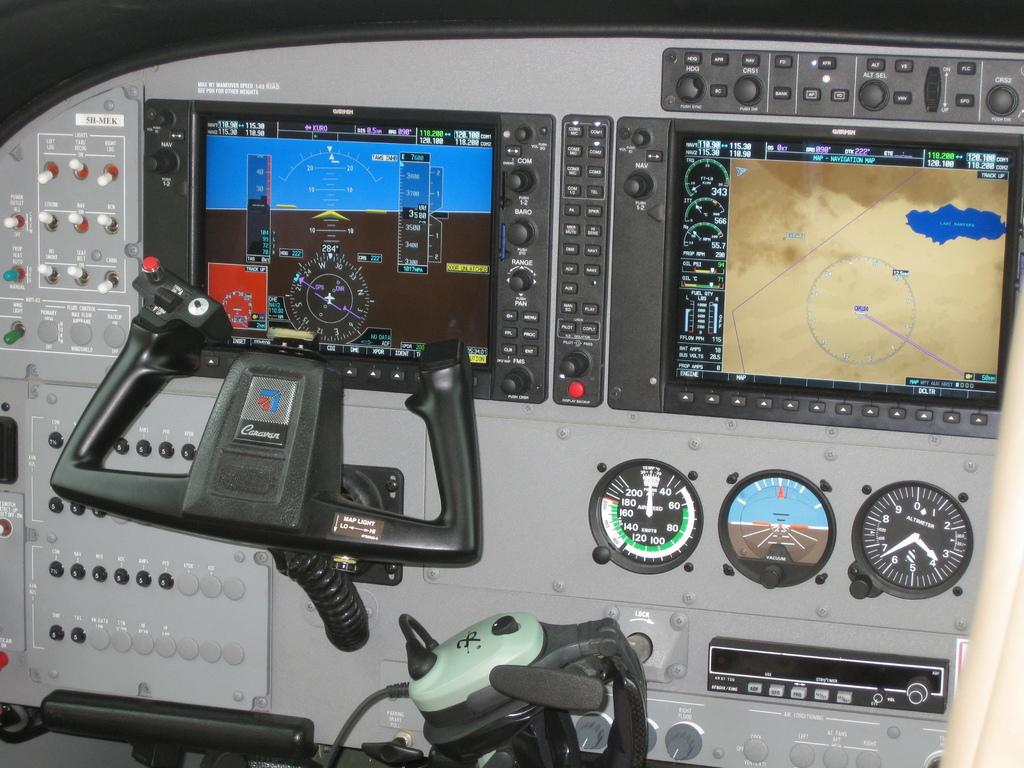<image>
Relay a brief, clear account of the picture shown. Cockpit of an airplane with the word Caravan on the steering wheel. 